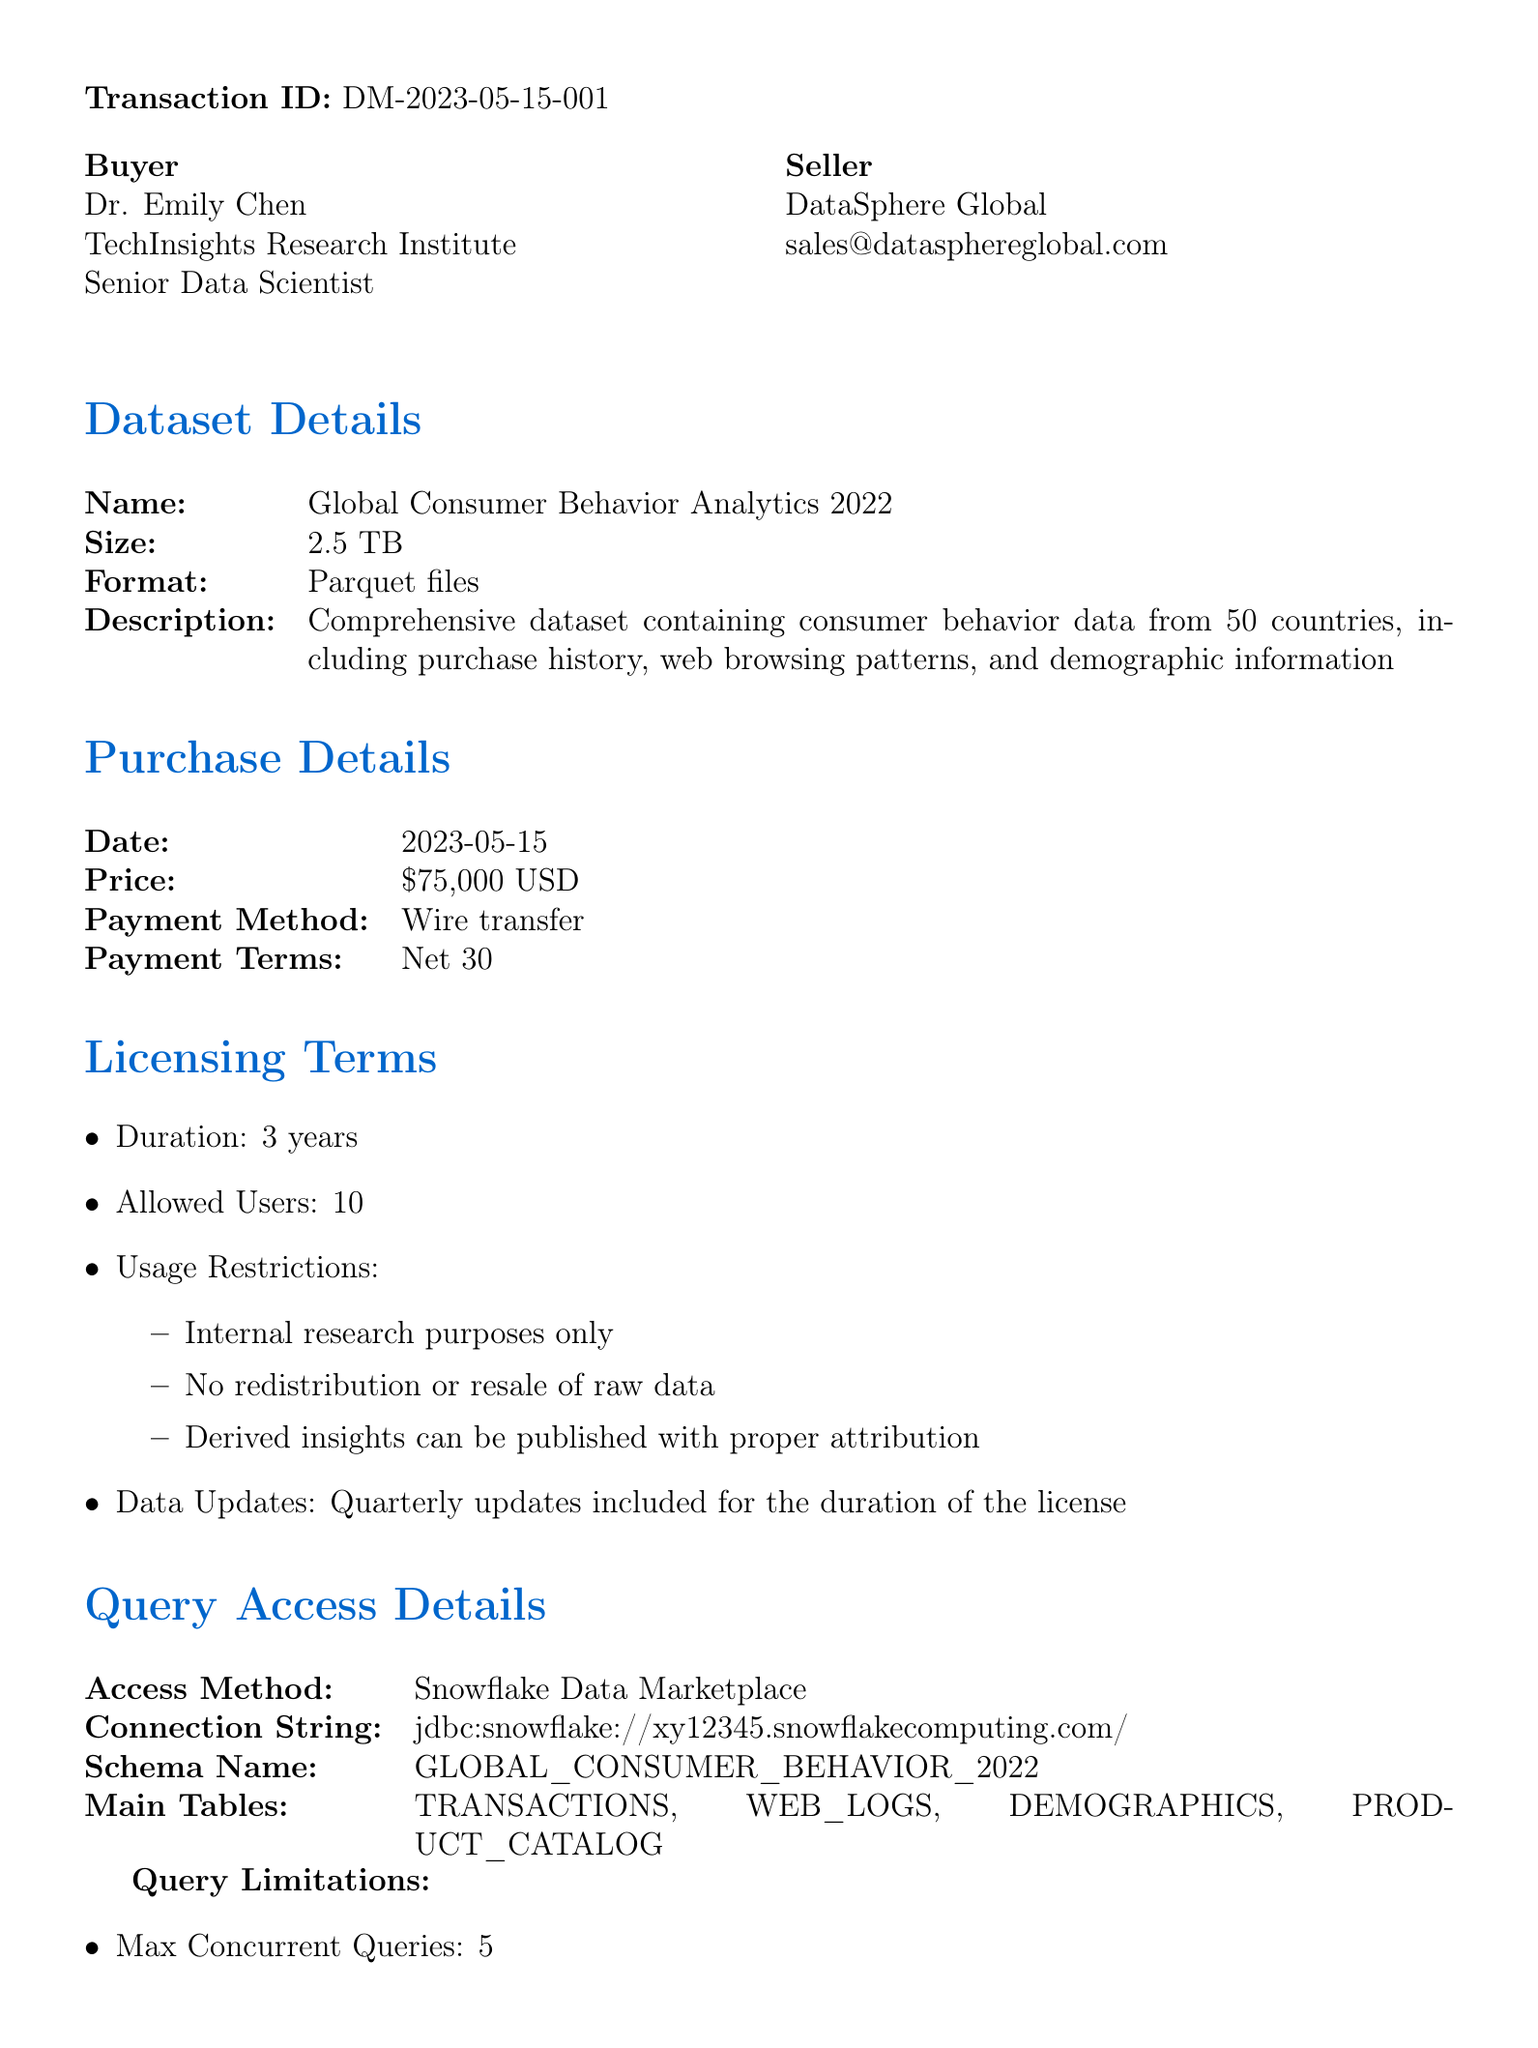What is the transaction ID? The transaction ID is listed at the beginning of the document, uniquely identifying the transaction.
Answer: DM-2023-05-15-001 Who is the buyer? The buyer's name and organization are specified under the buyer section.
Answer: Dr. Emily Chen What is the dataset size? The size of the dataset is explicitly mentioned in the dataset details.
Answer: 2.5 TB What are the payment terms? The payment terms are outlined under the purchase details.
Answer: Net 30 What is the duration of the licensing terms? The duration is specified in the licensing terms section.
Answer: 3 years How many allowed users are there? The maximum number of users permitted is stated in the licensing terms.
Answer: 10 What is the access method for the dataset? The method of access is described in the query access details section.
Answer: Snowflake Data Marketplace Is the dataset GDPR compliant? Compliance details regarding data protection are listed in the compliance and security section.
Answer: Fully GDPR compliant What is the early termination fee? The fee for early termination is detailed in the termination clause section.
Answer: 50% of remaining contract value 